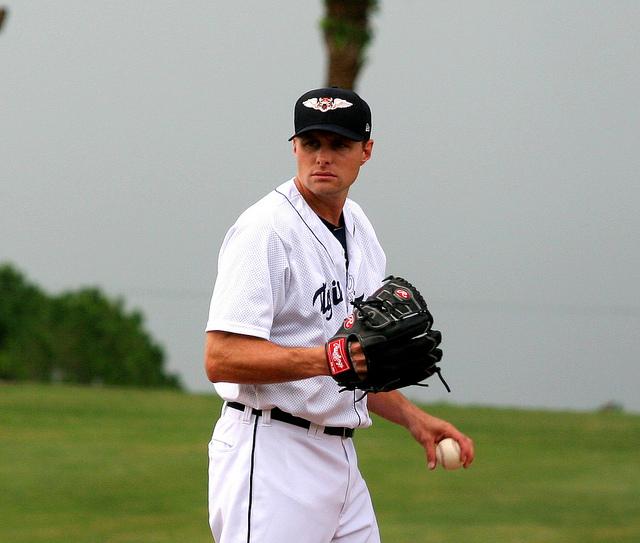Does the man have facial hair?
Write a very short answer. No. What hand is wearing the glove?
Keep it brief. Right. Is the man going to throw the ball?
Be succinct. Yes. What sport is he playing?
Be succinct. Baseball. What sport is this?
Concise answer only. Baseball. Is the athlete left or right handed?
Be succinct. Left. Which hand is the man wearing a glove on?
Answer briefly. Right. What color is this man's baseball mitt?
Be succinct. Black. What is the man catching?
Short answer required. Baseball. Is this a professional baseball player?
Keep it brief. Yes. What is the man holding?
Write a very short answer. Baseball. 